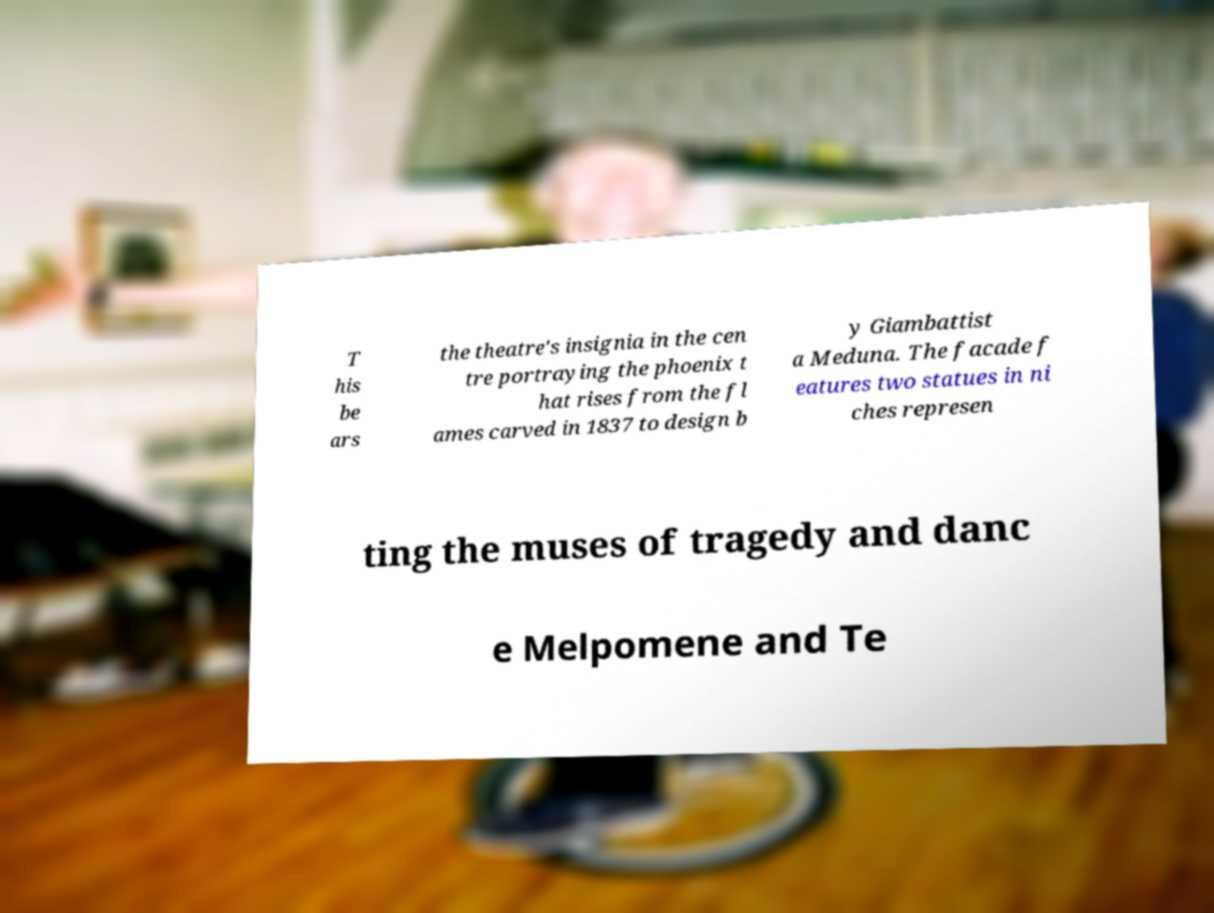Can you read and provide the text displayed in the image?This photo seems to have some interesting text. Can you extract and type it out for me? T his be ars the theatre's insignia in the cen tre portraying the phoenix t hat rises from the fl ames carved in 1837 to design b y Giambattist a Meduna. The facade f eatures two statues in ni ches represen ting the muses of tragedy and danc e Melpomene and Te 